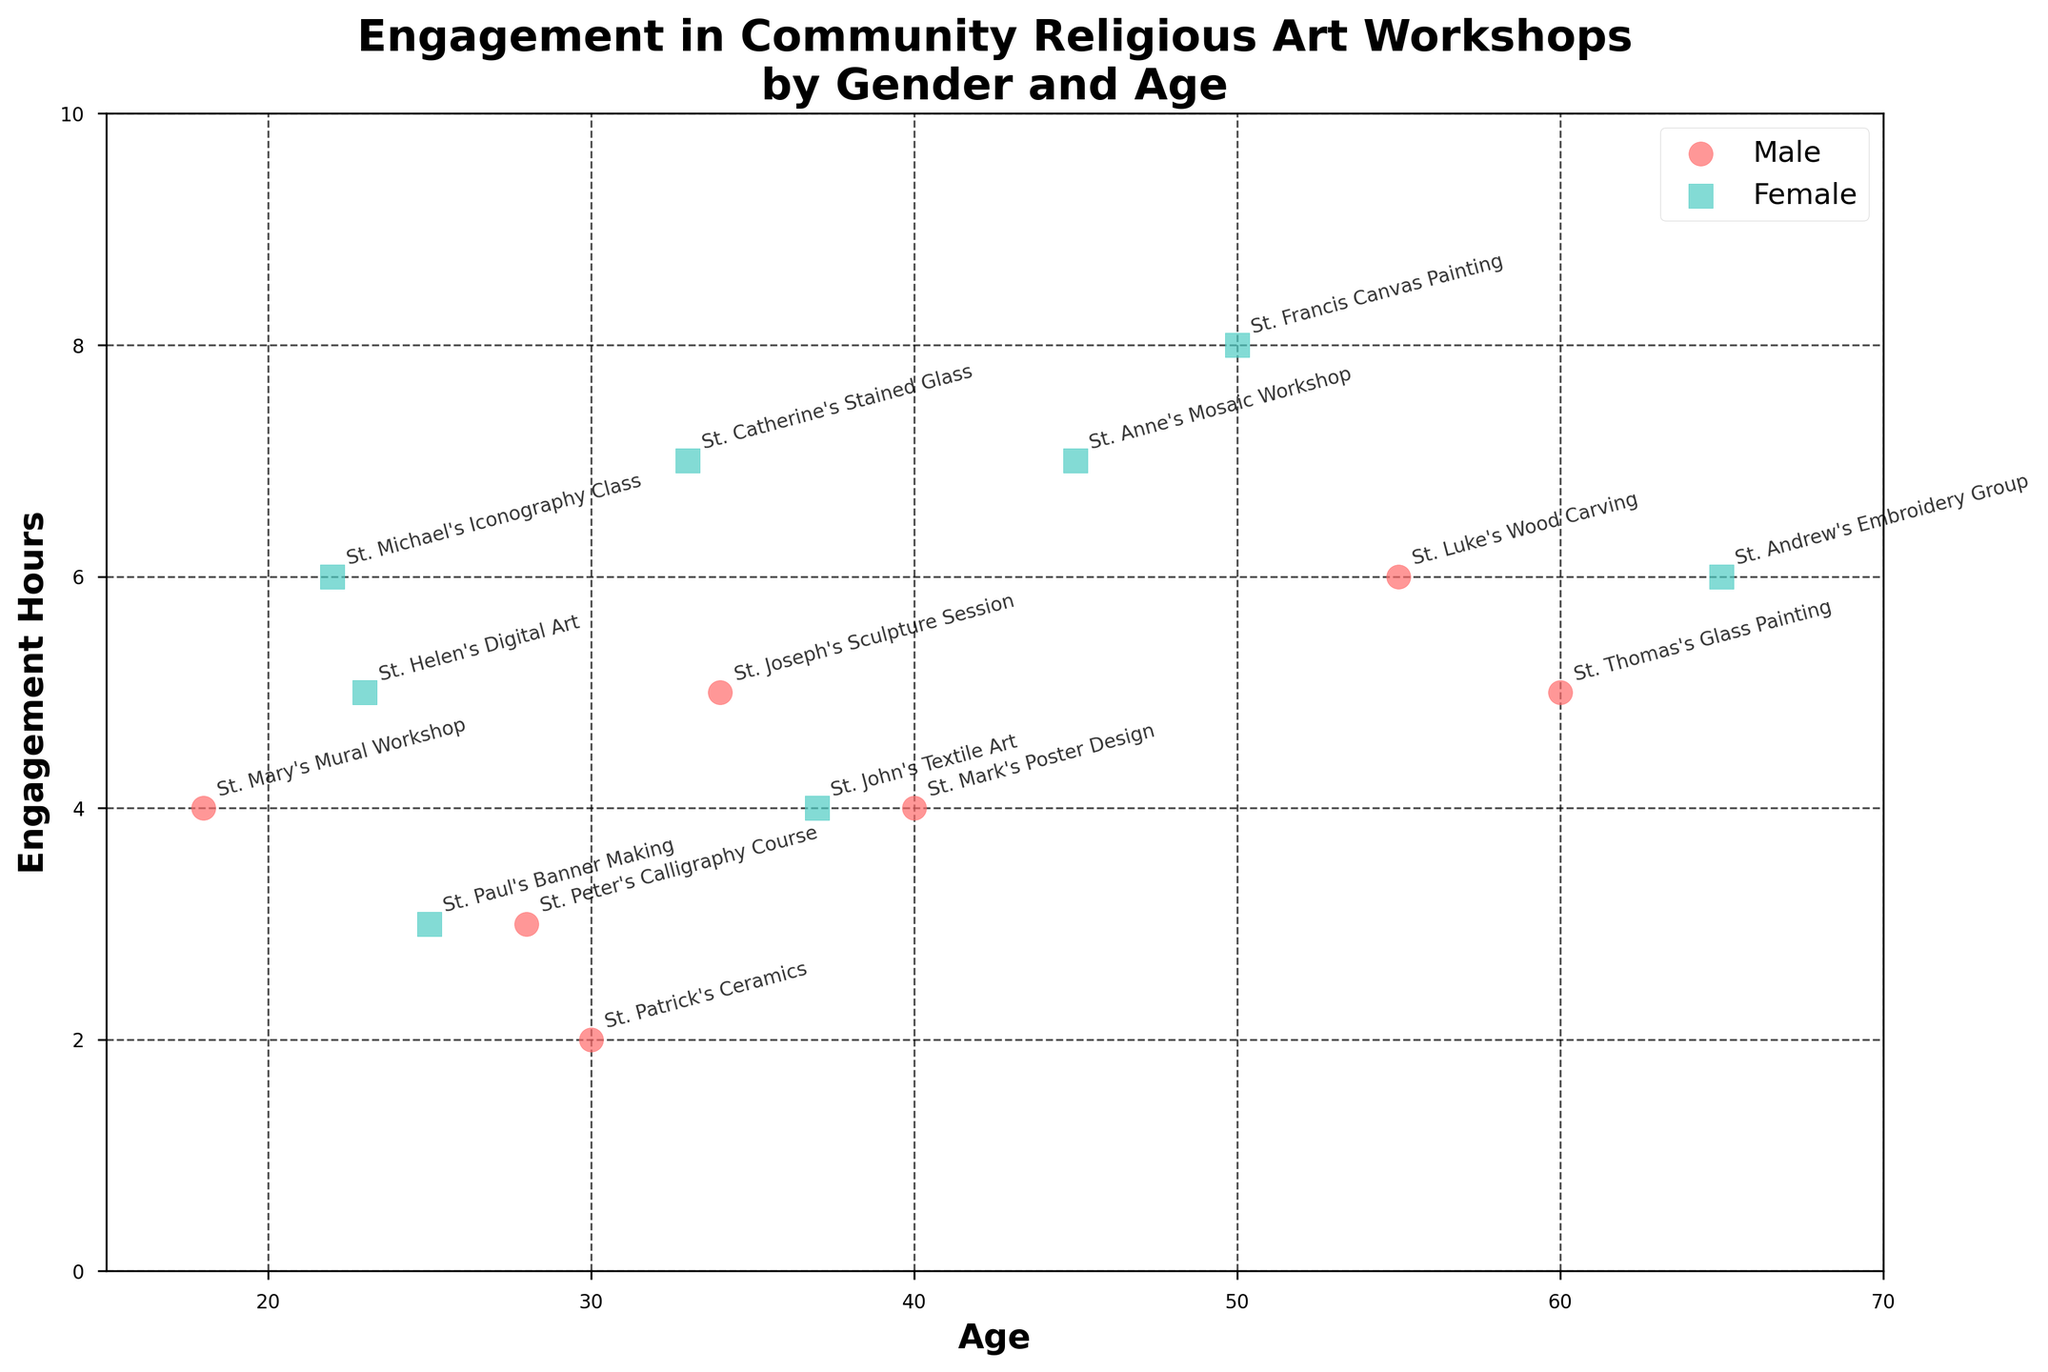How many workshops are represented in the figure? To find the number of workshops, we can count each individual data point labeled with a workshop name.
Answer: 15 What is the title of the figure? The title of the figure can be found at the top, which summarizes the main theme of the data presented.
Answer: Engagement in Community Religious Art Workshops by Gender and Age Which age group has the highest engagement hours for females? Identify the female participants, and then look for the data point with the highest value on the engagement hours axis.
Answer: 50 (8 hours) How many workshops have more than 5 engagement hours? Count the number of data points that are placed above the 5 engagement hours tick on the y-axis.
Answer: 7 What is the general trend of engagement hours with respect to age? Observing the scatter plot, we can see if there's any clear upward or downward trajectory based on the distribution of points.
Answer: No clear trend Which workshop has the lowest engagement hours for males? Look for male participants and then find the data point with the lowest value on the engagement hours axis.
Answer: St. Patrick's Ceramics (2 hours) Are there more male or female participants aged above 40? Identify the gender of participants aged above 40, and count how many male and female participants there are.
Answer: Female Is there a gender that generally spends more hours in workshops? Compare the overall spread and density of engagement hours for both gender markers (circle for males and square for females).
Answer: Female What is the average engagement hours for all participants above the age of 30? First, sum up the engagement hours of participants above 30. There are 8 participants (34, 45, 50, 65, 60, 37, 55, 40 years old) with hours (5, 7, 8, 6, 5, 4, 6, 4). The total is 45 hours, and the average is 45/8 = 5.625.
Answer: 5.625 Is there a noticeable difference in engagement hours between younger (below 30) and older (30 and above) participants? Calculate the average engagement hours for both groups. Below 30 have hours (4, 6, 3, 2, 5, 3) summing to 23, with 6 participants, so 23/6 = 3.833. Above 30 have hours (5, 7, 8, 6, 5, 4, 6, 4) summing to 45, with 8 participants, so 45/8 = 5.625.
Answer: Older participants engage more 